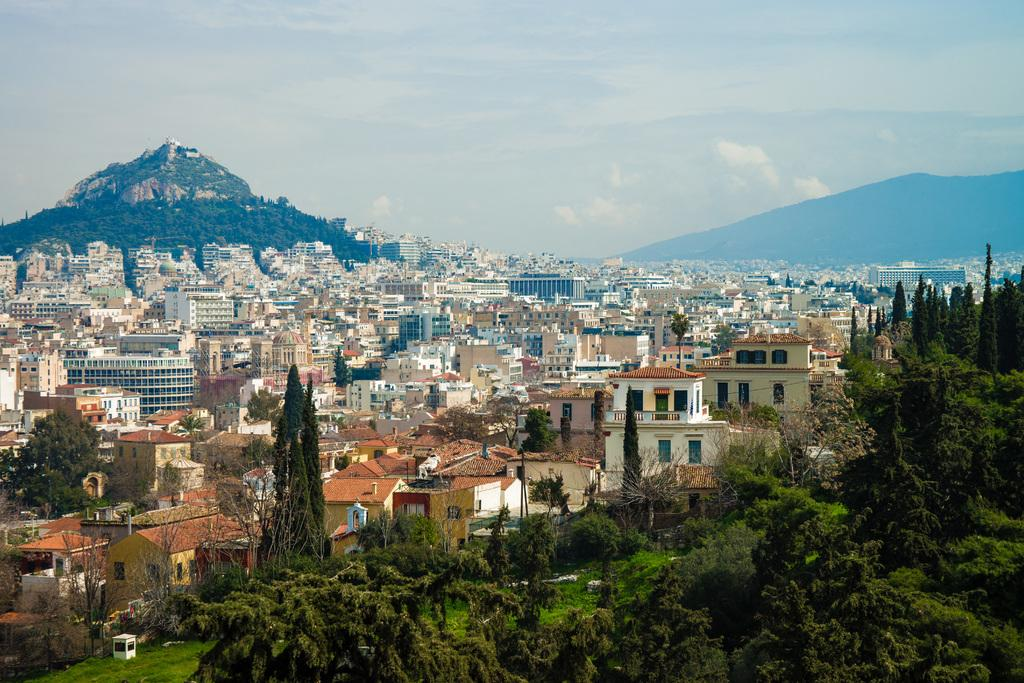What type of structures can be seen in the image? There are buildings in the image. What natural feature is present in the image? There is a mountain in the image. What type of vegetation can be seen in the image? There are trees in the image. What is visible at the top of the image? The sky is visible at the top of the image. What can be observed in the sky? Clouds are present in the sky. What type of quiver can be seen hanging on the mountain in the image? There is no quiver present in the image; it features buildings, a mountain, trees, and clouds in the sky. What hobbies do the buildings in the image engage in? Buildings do not engage in hobbies, as they are inanimate structures. 